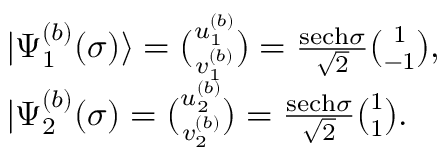<formula> <loc_0><loc_0><loc_500><loc_500>\begin{array} { r l } & { | \Psi _ { 1 } ^ { ( b ) } ( \sigma ) \rangle = \binom { u _ { 1 } ^ { ( b ) } } { v _ { 1 } ^ { ( b ) } } = \frac { s e c h \sigma } { \sqrt { 2 } } \binom { 1 } { - 1 } , } \\ & { | \Psi _ { 2 } ^ { ( b ) } ( \sigma ) = \binom { u _ { 2 } ^ { ( b ) } } { v _ { 2 } ^ { ( b ) } } = \frac { s e c h \sigma } { \sqrt { 2 } } \binom { 1 } { 1 } . } \end{array}</formula> 